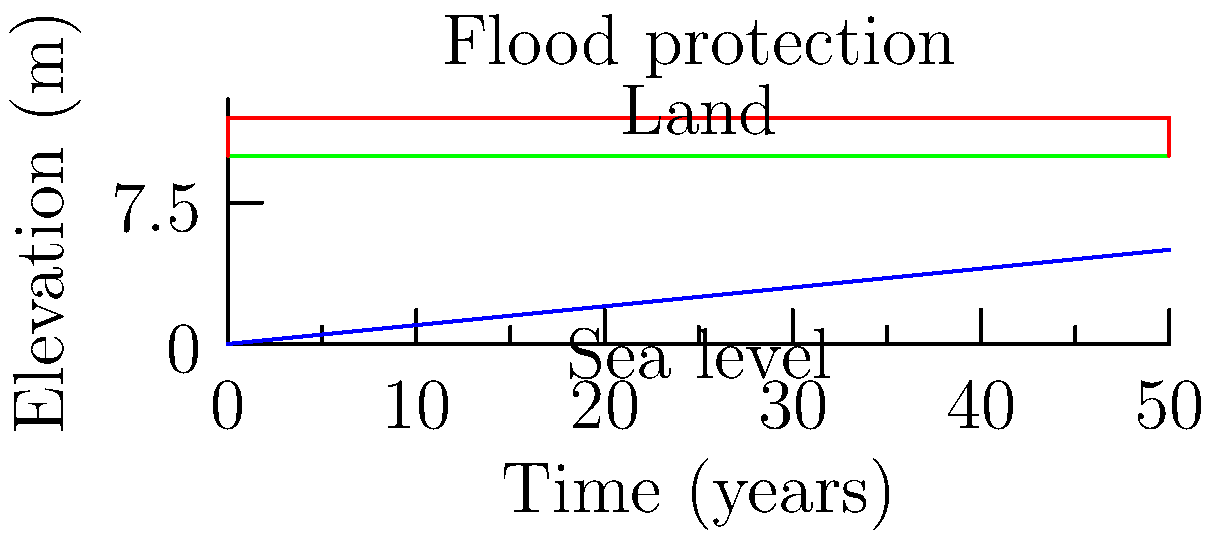Based on the graph showing sea-level rise projections and current land elevation for a coastal indigenous settlement, what minimum height should the flood protection measures be to safeguard the community for the next 50 years? To determine the minimum height for flood protection measures, we need to follow these steps:

1. Analyze the graph:
   - The green line represents the current land elevation at 10 meters.
   - The blue line shows the projected sea-level rise over time.
   - The red line indicates the flood protection measures.

2. Determine the sea-level rise after 50 years:
   - The graph shows that sea level rises linearly over time.
   - At 50 years, the sea level reaches 5 meters (0.1 m/year * 50 years).

3. Calculate the total water level:
   - Initial sea level: 0 meters
   - Sea-level rise: 5 meters
   - Total water level after 50 years: 0 + 5 = 5 meters

4. Consider safety factors:
   - We should add a safety margin to account for potential storm surges, waves, and uncertainties in projections.
   - A common practice is to add at least 1 meter as a safety factor.

5. Calculate the minimum height for flood protection:
   - Minimum height = Total water level + Safety factor
   - Minimum height = 5 meters + 1 meter = 6 meters

6. Compare with land elevation:
   - The land elevation is 10 meters.
   - The flood protection measures should extend from the land elevation upwards.
   - Minimum height above land = 6 meters - 10 meters = -4 meters

Since the result is negative, it means the current land elevation is higher than the minimum required protection height. However, to ensure long-term safety and account for potential accelerated sea-level rise, it's advisable to implement some flood protection measures.
Answer: 2 meters above current land elevation 